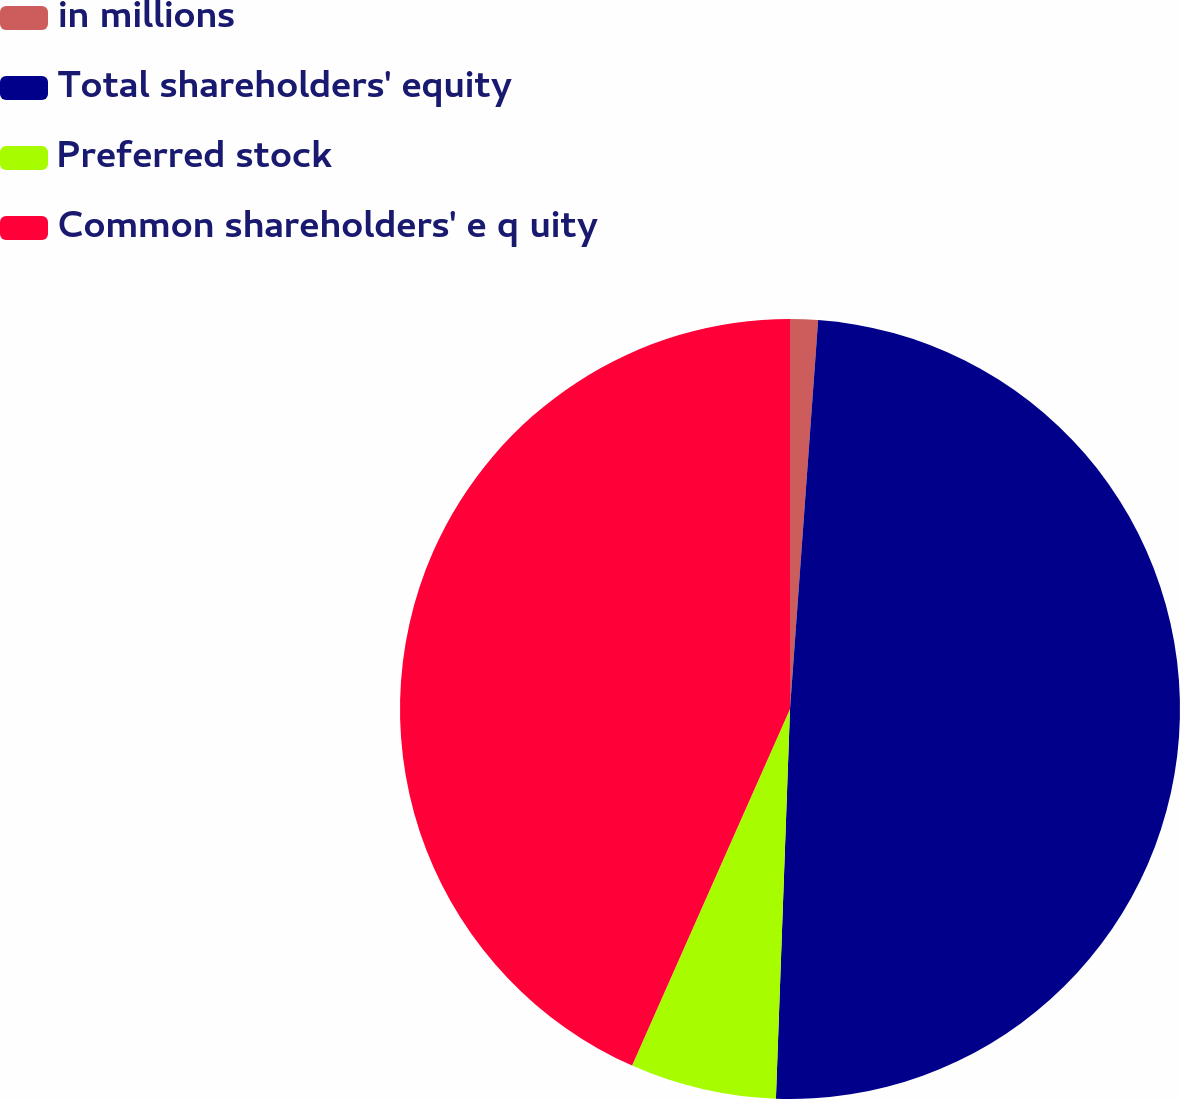<chart> <loc_0><loc_0><loc_500><loc_500><pie_chart><fcel>in millions<fcel>Total shareholders' equity<fcel>Preferred stock<fcel>Common shareholders' e q uity<nl><fcel>1.15%<fcel>49.42%<fcel>6.06%<fcel>43.36%<nl></chart> 